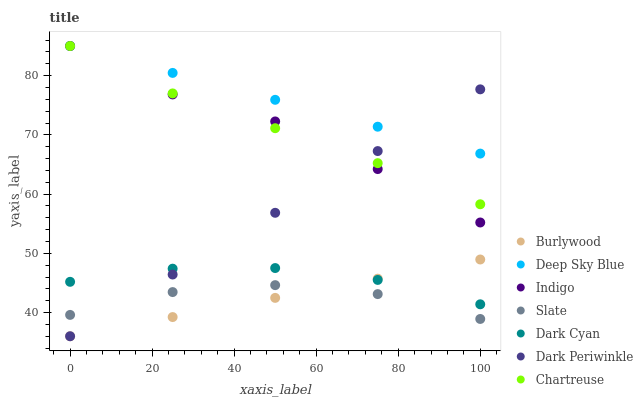Does Burlywood have the minimum area under the curve?
Answer yes or no. Yes. Does Deep Sky Blue have the maximum area under the curve?
Answer yes or no. Yes. Does Slate have the minimum area under the curve?
Answer yes or no. No. Does Slate have the maximum area under the curve?
Answer yes or no. No. Is Deep Sky Blue the smoothest?
Answer yes or no. Yes. Is Indigo the roughest?
Answer yes or no. Yes. Is Burlywood the smoothest?
Answer yes or no. No. Is Burlywood the roughest?
Answer yes or no. No. Does Burlywood have the lowest value?
Answer yes or no. Yes. Does Slate have the lowest value?
Answer yes or no. No. Does Deep Sky Blue have the highest value?
Answer yes or no. Yes. Does Burlywood have the highest value?
Answer yes or no. No. Is Dark Cyan less than Chartreuse?
Answer yes or no. Yes. Is Deep Sky Blue greater than Burlywood?
Answer yes or no. Yes. Does Deep Sky Blue intersect Dark Periwinkle?
Answer yes or no. Yes. Is Deep Sky Blue less than Dark Periwinkle?
Answer yes or no. No. Is Deep Sky Blue greater than Dark Periwinkle?
Answer yes or no. No. Does Dark Cyan intersect Chartreuse?
Answer yes or no. No. 